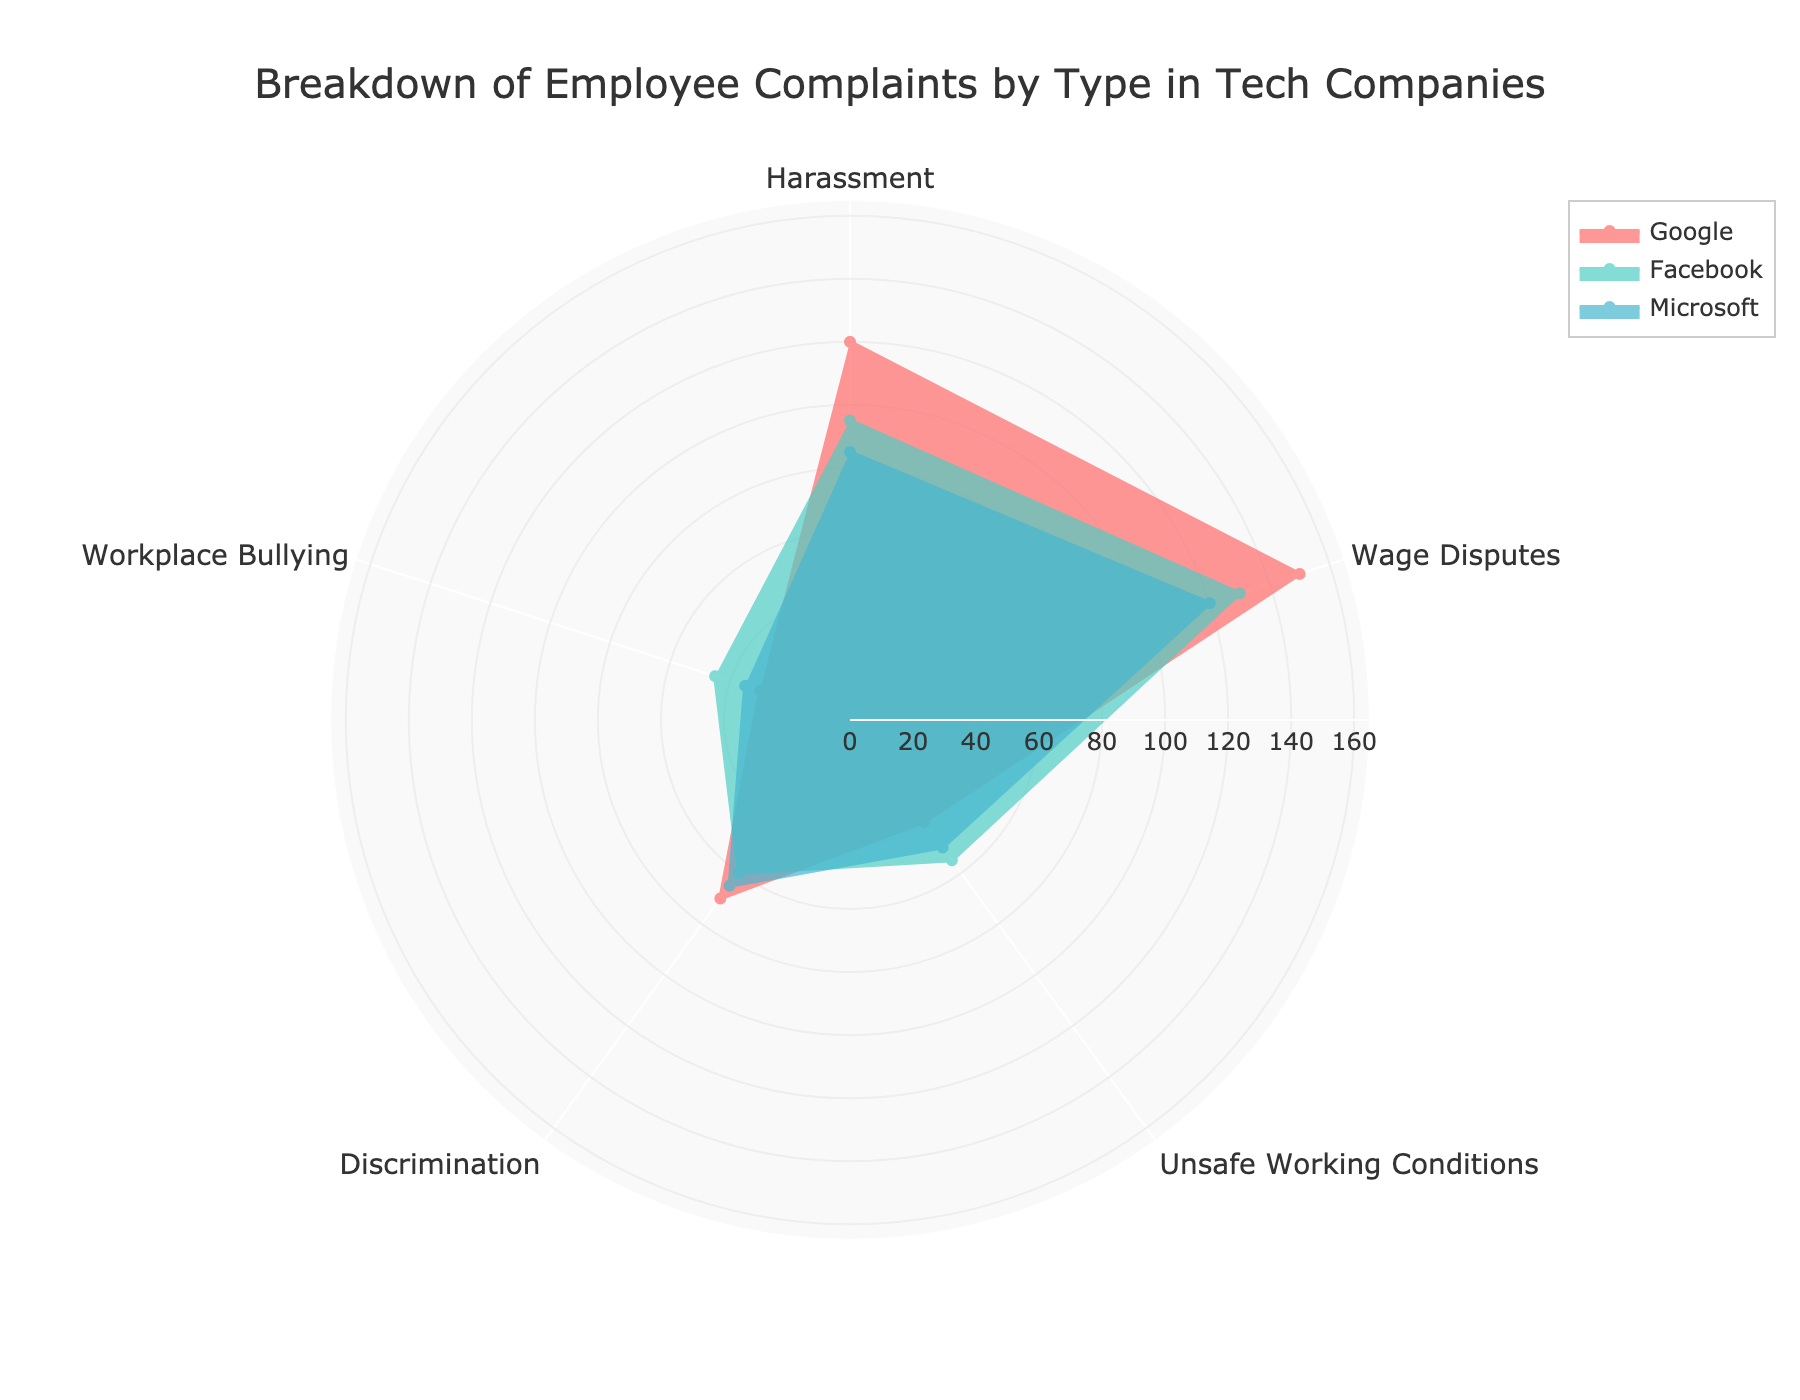How many types of employee complaints are illustrated in the figure? The figure uses different angular axes to show the distribution of complaints. Counting the unique labels on these axes gives the number of complaint types.
Answer: 5 Which company has the highest number of complaints overall? Summing the counts of each complaint type for each company shows the total number of complaints. Google: 410, Facebook: 385, Microsoft: 355.
Answer: Google What is the range of the radial axis? The radial axis ranges based on the highest complaint count with some extra padding. Visible inspection shows it goes up to slightly more than the highest value, which is 150 for wage disputes.
Answer: 165 Compare the number of wage dispute complaints between Google and Facebook. By inspecting the lengths on the radial axis for wage disputes, Google has 150 and Facebook has 130.
Answer: Google (150 is greater than 130) What is the combined number of harassment complaints across all companies? Summing up harassment complaints for Google (120), Facebook (95), and Microsoft (85). 120 + 95 + 85 = 300.
Answer: 300 Which complaint type has the lowest count for Google? By comparing the radial distances for Google, the shortest distance pertains to "Workplace Bullying" with a count of 30.
Answer: Workplace Bullying What is the difference in the number of unsafe working condition complaints between Facebook and Microsoft? From the radial distances, Facebook has 55 and Microsoft has 50 complaints for unsafe working conditions. The difference is 55 - 50 = 5.
Answer: 5 Are there more discrimination complaints or harassment complaints for Microsoft? Comparing the radial distances, Microsoft has 65 discrimination complaints and 85 harassment complaints.
Answer: Harassment Which company has the maximum number of workplace bullying complaints? By comparing the radial distances for workplace bullying across all companies, Facebook has the highest count at 45.
Answer: Facebook 